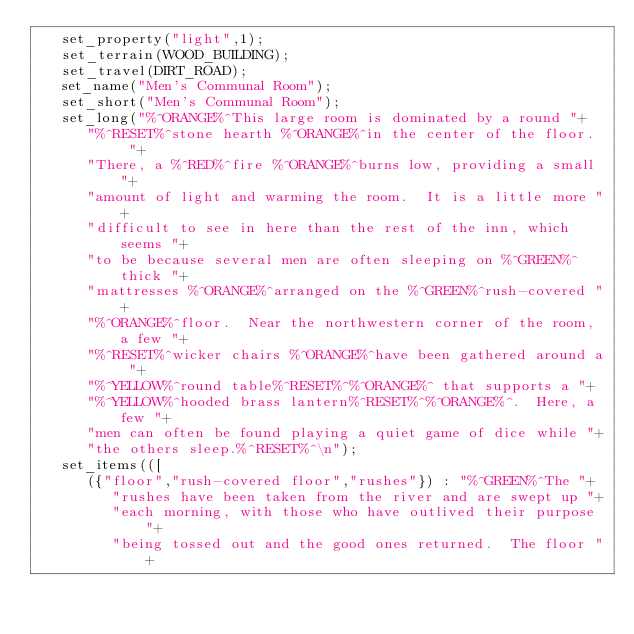Convert code to text. <code><loc_0><loc_0><loc_500><loc_500><_C_>   set_property("light",1);
   set_terrain(WOOD_BUILDING);
   set_travel(DIRT_ROAD);
   set_name("Men's Communal Room");
   set_short("Men's Communal Room");
   set_long("%^ORANGE%^This large room is dominated by a round "+
      "%^RESET%^stone hearth %^ORANGE%^in the center of the floor.  "+
      "There, a %^RED%^fire %^ORANGE%^burns low, providing a small "+
      "amount of light and warming the room.  It is a little more "+
      "difficult to see in here than the rest of the inn, which seems "+
      "to be because several men are often sleeping on %^GREEN%^thick "+
      "mattresses %^ORANGE%^arranged on the %^GREEN%^rush-covered "+
      "%^ORANGE%^floor.  Near the northwestern corner of the room, a few "+
      "%^RESET%^wicker chairs %^ORANGE%^have been gathered around a "+
      "%^YELLOW%^round table%^RESET%^%^ORANGE%^ that supports a "+
      "%^YELLOW%^hooded brass lantern%^RESET%^%^ORANGE%^.  Here, a few "+
      "men can often be found playing a quiet game of dice while "+
      "the others sleep.%^RESET%^\n");
   set_items(([
      ({"floor","rush-covered floor","rushes"}) : "%^GREEN%^The "+
         "rushes have been taken from the river and are swept up "+
         "each morning, with those who have outlived their purpose "+
         "being tossed out and the good ones returned.  The floor "+</code> 